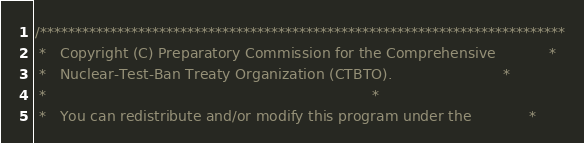<code> <loc_0><loc_0><loc_500><loc_500><_C_>/***************************************************************************
 *   Copyright (C) Preparatory Commission for the Comprehensive            *
 *   Nuclear-Test-Ban Treaty Organization (CTBTO).                         *
 *                                                                         *
 *   You can redistribute and/or modify this program under the             *</code> 